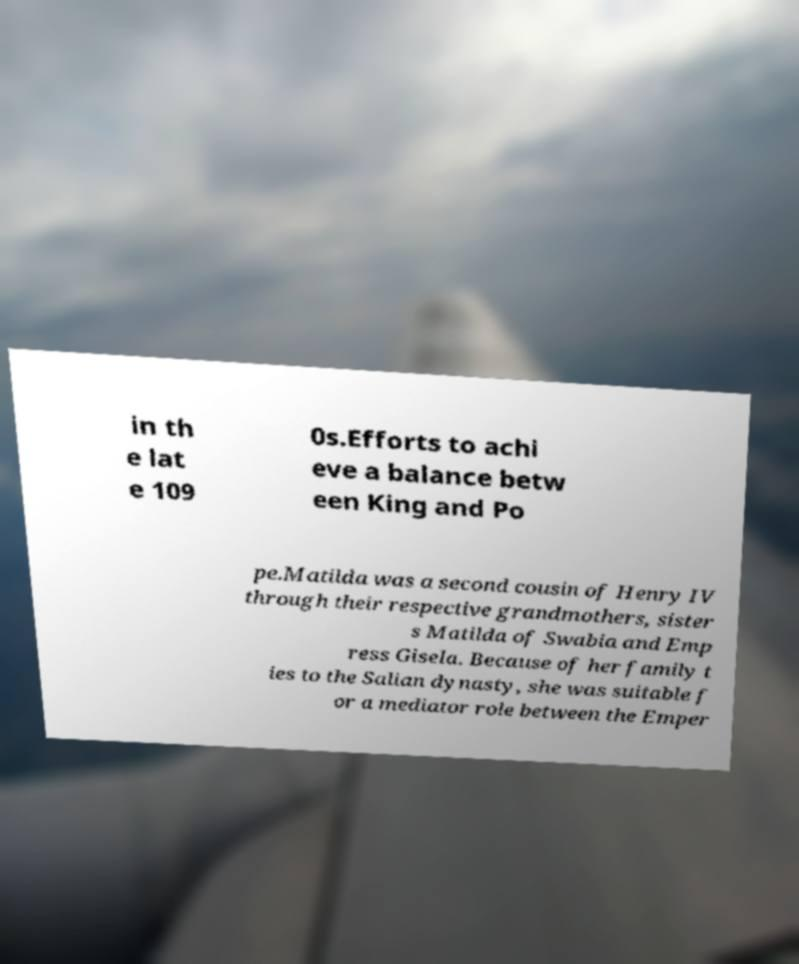Please identify and transcribe the text found in this image. in th e lat e 109 0s.Efforts to achi eve a balance betw een King and Po pe.Matilda was a second cousin of Henry IV through their respective grandmothers, sister s Matilda of Swabia and Emp ress Gisela. Because of her family t ies to the Salian dynasty, she was suitable f or a mediator role between the Emper 